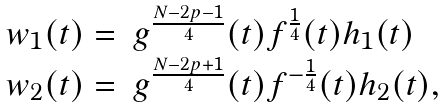<formula> <loc_0><loc_0><loc_500><loc_500>\begin{array} { l l } w _ { 1 } ( t ) = & g ^ { \frac { N - 2 p - 1 } { 4 } } ( t ) f ^ { \frac { 1 } { 4 } } ( t ) h _ { 1 } ( t ) \\ w _ { 2 } ( t ) = & g ^ { \frac { N - 2 p + 1 } { 4 } } ( t ) f ^ { - \frac { 1 } { 4 } } ( t ) h _ { 2 } ( t ) , \end{array}</formula> 